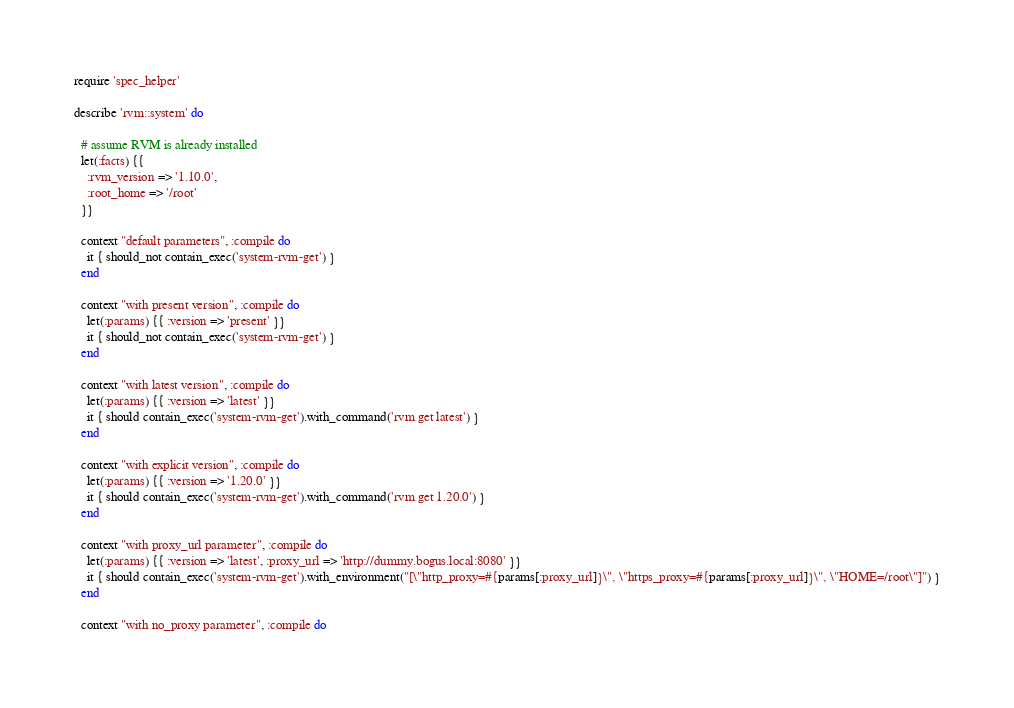Convert code to text. <code><loc_0><loc_0><loc_500><loc_500><_Ruby_>require 'spec_helper'

describe 'rvm::system' do

  # assume RVM is already installed
  let(:facts) {{
    :rvm_version => '1.10.0',
    :root_home => '/root'
  }}

  context "default parameters", :compile do
    it { should_not contain_exec('system-rvm-get') }
  end

  context "with present version", :compile do
    let(:params) {{ :version => 'present' }}
    it { should_not contain_exec('system-rvm-get') }
  end

  context "with latest version", :compile do
    let(:params) {{ :version => 'latest' }}
    it { should contain_exec('system-rvm-get').with_command('rvm get latest') }
  end

  context "with explicit version", :compile do
    let(:params) {{ :version => '1.20.0' }}
    it { should contain_exec('system-rvm-get').with_command('rvm get 1.20.0') }
  end

  context "with proxy_url parameter", :compile do
    let(:params) {{ :version => 'latest', :proxy_url => 'http://dummy.bogus.local:8080' }}
    it { should contain_exec('system-rvm-get').with_environment("[\"http_proxy=#{params[:proxy_url]}\", \"https_proxy=#{params[:proxy_url]}\", \"HOME=/root\"]") }
  end

  context "with no_proxy parameter", :compile do</code> 